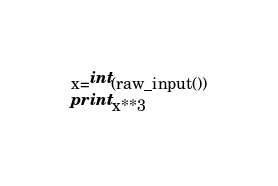<code> <loc_0><loc_0><loc_500><loc_500><_Python_>x=int(raw_input())
print x**3</code> 